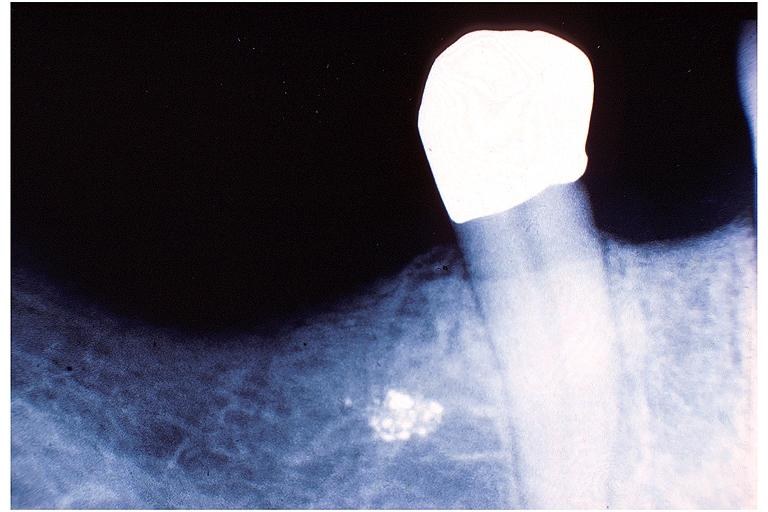does this image show amalgam tattoo?
Answer the question using a single word or phrase. Yes 